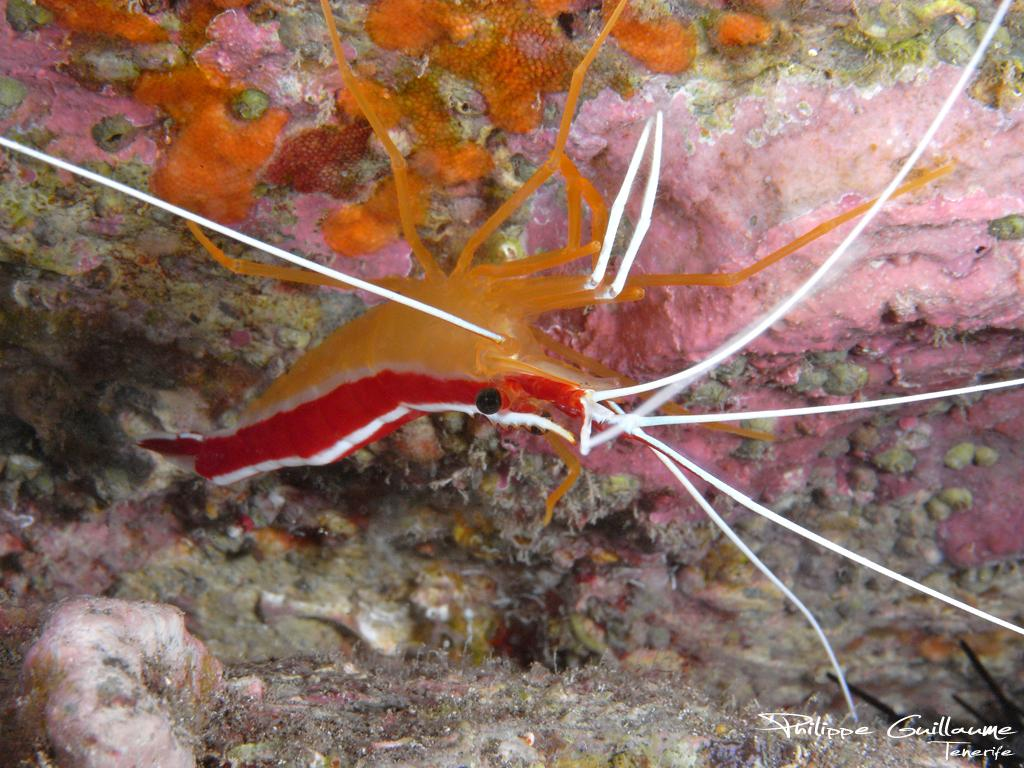What type of animal is in the image? There is an aquatic animal in the image. What colors can be seen on the animal? The animal has orange and red colors. What can be observed about the background of the image? There is a colorful background in the image. Can you tell me how the animal is enjoying its meal in the image? There is no indication of the animal eating a meal in the image. 